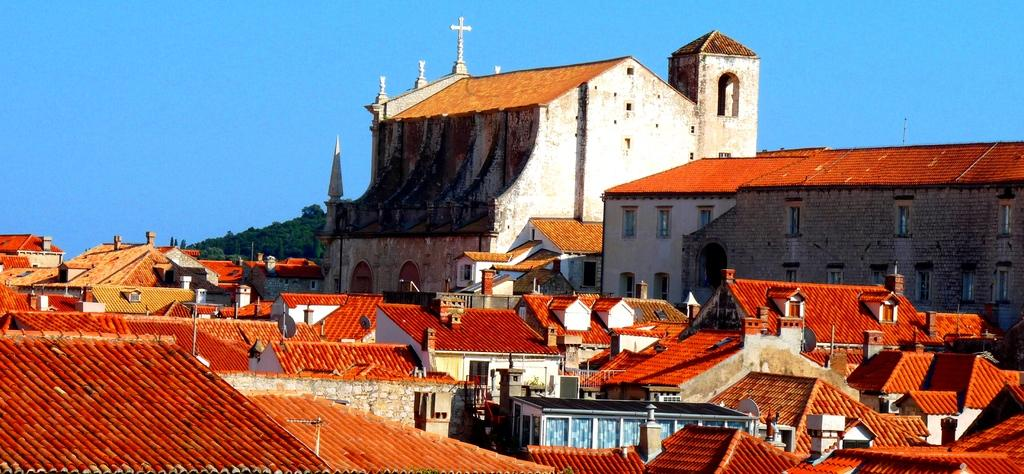What types of structures are present in the image? There are buildings and houses in the image. What feature can be seen on the structures in the image? Windows are visible in the image. What can be seen in the background of the image? There are trees and the sky visible in the background of the image. How does the fireman pull the buildings in the image? There is no fireman present in the image, and the buildings are not being pulled. 